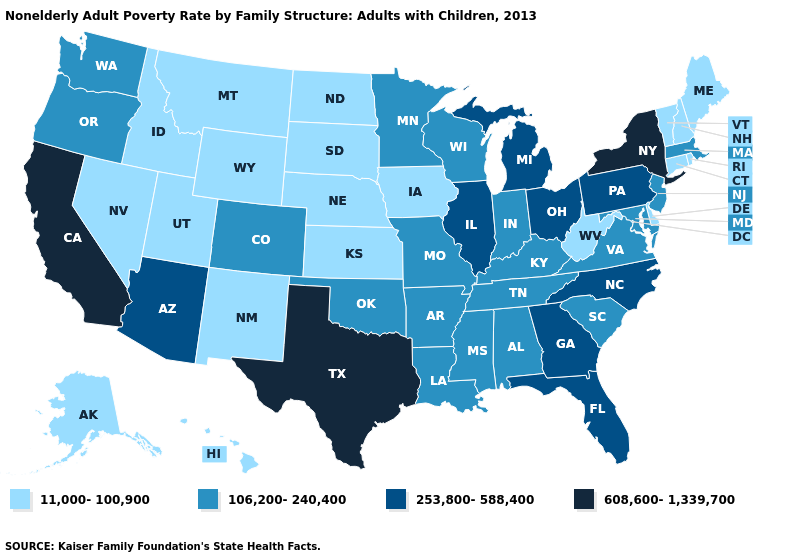Does Texas have the highest value in the South?
Answer briefly. Yes. Does Indiana have the lowest value in the USA?
Keep it brief. No. What is the highest value in the West ?
Give a very brief answer. 608,600-1,339,700. Which states hav the highest value in the Northeast?
Keep it brief. New York. Among the states that border Maine , which have the lowest value?
Answer briefly. New Hampshire. What is the value of Washington?
Give a very brief answer. 106,200-240,400. Name the states that have a value in the range 253,800-588,400?
Write a very short answer. Arizona, Florida, Georgia, Illinois, Michigan, North Carolina, Ohio, Pennsylvania. Is the legend a continuous bar?
Concise answer only. No. What is the value of North Dakota?
Answer briefly. 11,000-100,900. What is the lowest value in the USA?
Keep it brief. 11,000-100,900. What is the highest value in the West ?
Write a very short answer. 608,600-1,339,700. What is the highest value in the South ?
Give a very brief answer. 608,600-1,339,700. Does the first symbol in the legend represent the smallest category?
Write a very short answer. Yes. Does the first symbol in the legend represent the smallest category?
Concise answer only. Yes. Name the states that have a value in the range 253,800-588,400?
Be succinct. Arizona, Florida, Georgia, Illinois, Michigan, North Carolina, Ohio, Pennsylvania. 